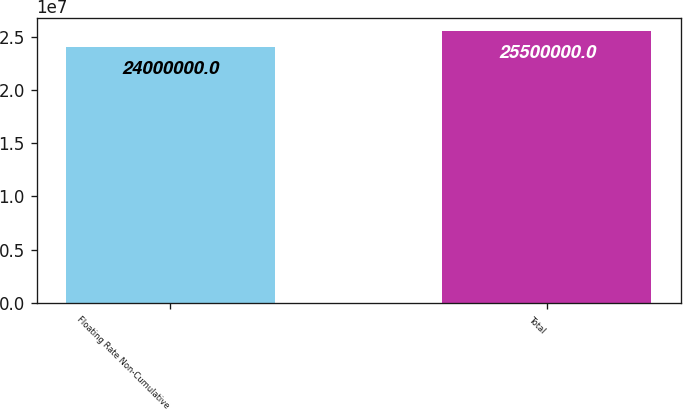Convert chart. <chart><loc_0><loc_0><loc_500><loc_500><bar_chart><fcel>Floating Rate Non-Cumulative<fcel>Total<nl><fcel>2.4e+07<fcel>2.55e+07<nl></chart> 